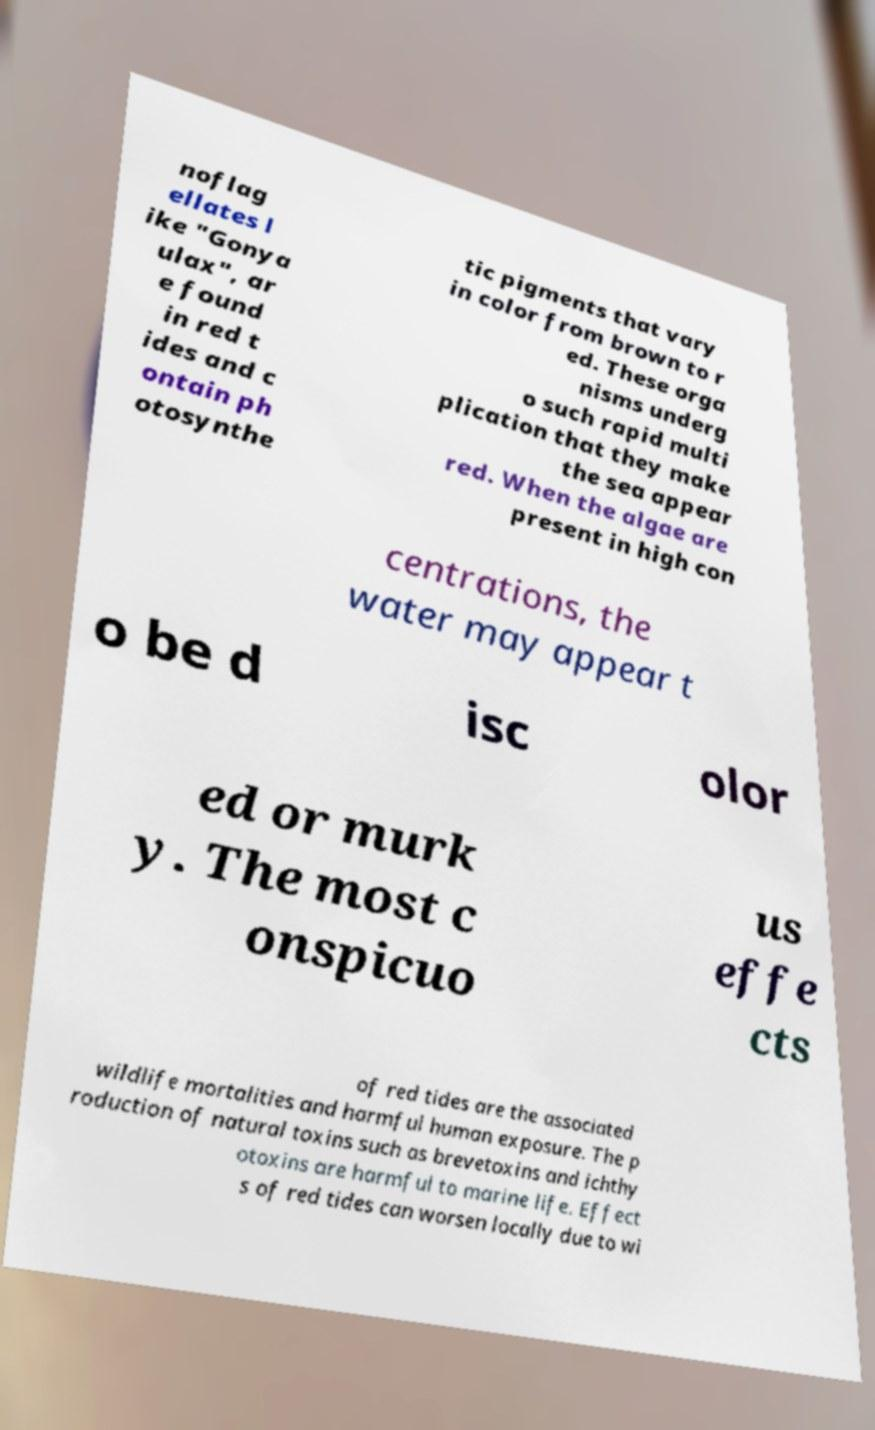I need the written content from this picture converted into text. Can you do that? noflag ellates l ike "Gonya ulax", ar e found in red t ides and c ontain ph otosynthe tic pigments that vary in color from brown to r ed. These orga nisms underg o such rapid multi plication that they make the sea appear red. When the algae are present in high con centrations, the water may appear t o be d isc olor ed or murk y. The most c onspicuo us effe cts of red tides are the associated wildlife mortalities and harmful human exposure. The p roduction of natural toxins such as brevetoxins and ichthy otoxins are harmful to marine life. Effect s of red tides can worsen locally due to wi 